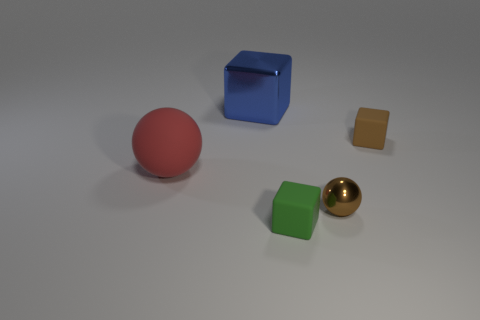There is another rubber thing that is the same size as the blue object; what is its shape?
Your answer should be compact. Sphere. Are the sphere that is on the left side of the blue object and the small cube behind the brown metallic ball made of the same material?
Give a very brief answer. Yes. What number of rubber things have the same size as the metallic sphere?
Your response must be concise. 2. There is a matte thing that is the same color as the small ball; what is its shape?
Offer a very short reply. Cube. What material is the cube that is in front of the big red ball?
Offer a very short reply. Rubber. What number of other blue metal things have the same shape as the big metal object?
Offer a very short reply. 0. There is a tiny brown thing that is made of the same material as the large red sphere; what shape is it?
Offer a very short reply. Cube. There is a brown thing that is in front of the tiny rubber thing behind the tiny brown metal ball on the left side of the small brown rubber cube; what is its shape?
Make the answer very short. Sphere. Is the number of small brown balls greater than the number of cyan rubber balls?
Provide a short and direct response. Yes. What material is the other small object that is the same shape as the red rubber thing?
Ensure brevity in your answer.  Metal. 